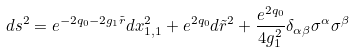<formula> <loc_0><loc_0><loc_500><loc_500>d s ^ { 2 } = e ^ { - 2 q _ { 0 } - 2 g _ { 1 } \tilde { r } } d x ^ { 2 } _ { 1 , 1 } + e ^ { 2 q _ { 0 } } d \tilde { r } ^ { 2 } + \frac { e ^ { 2 q _ { 0 } } } { 4 g _ { 1 } ^ { 2 } } \delta _ { \alpha \beta } \sigma ^ { \alpha } \sigma ^ { \beta }</formula> 